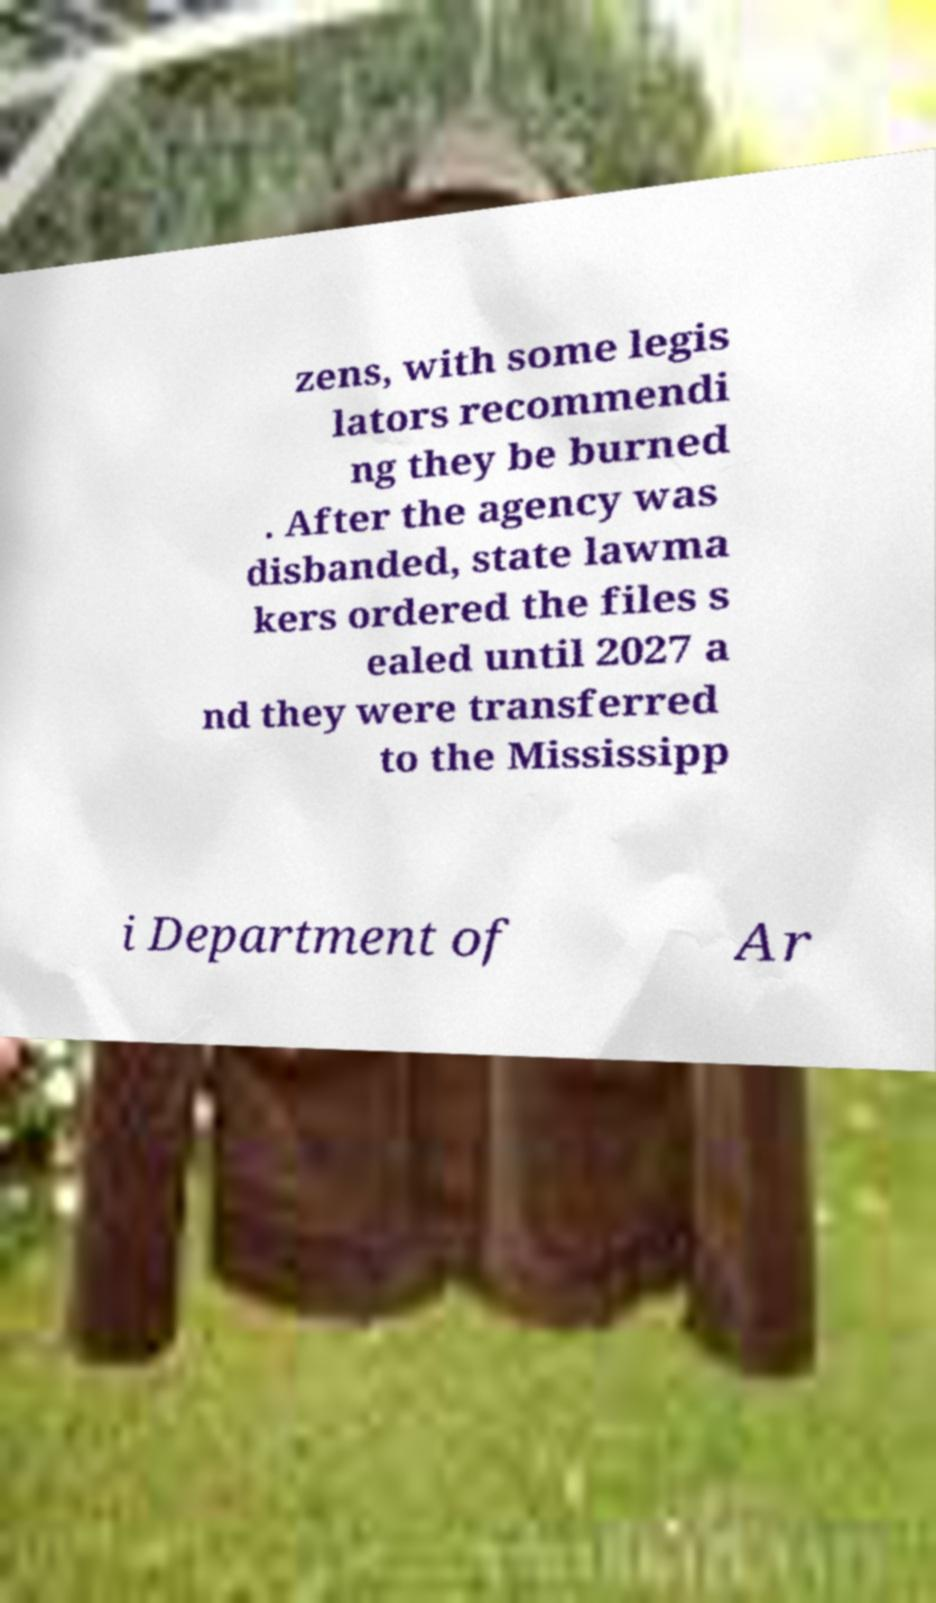For documentation purposes, I need the text within this image transcribed. Could you provide that? zens, with some legis lators recommendi ng they be burned . After the agency was disbanded, state lawma kers ordered the files s ealed until 2027 a nd they were transferred to the Mississipp i Department of Ar 